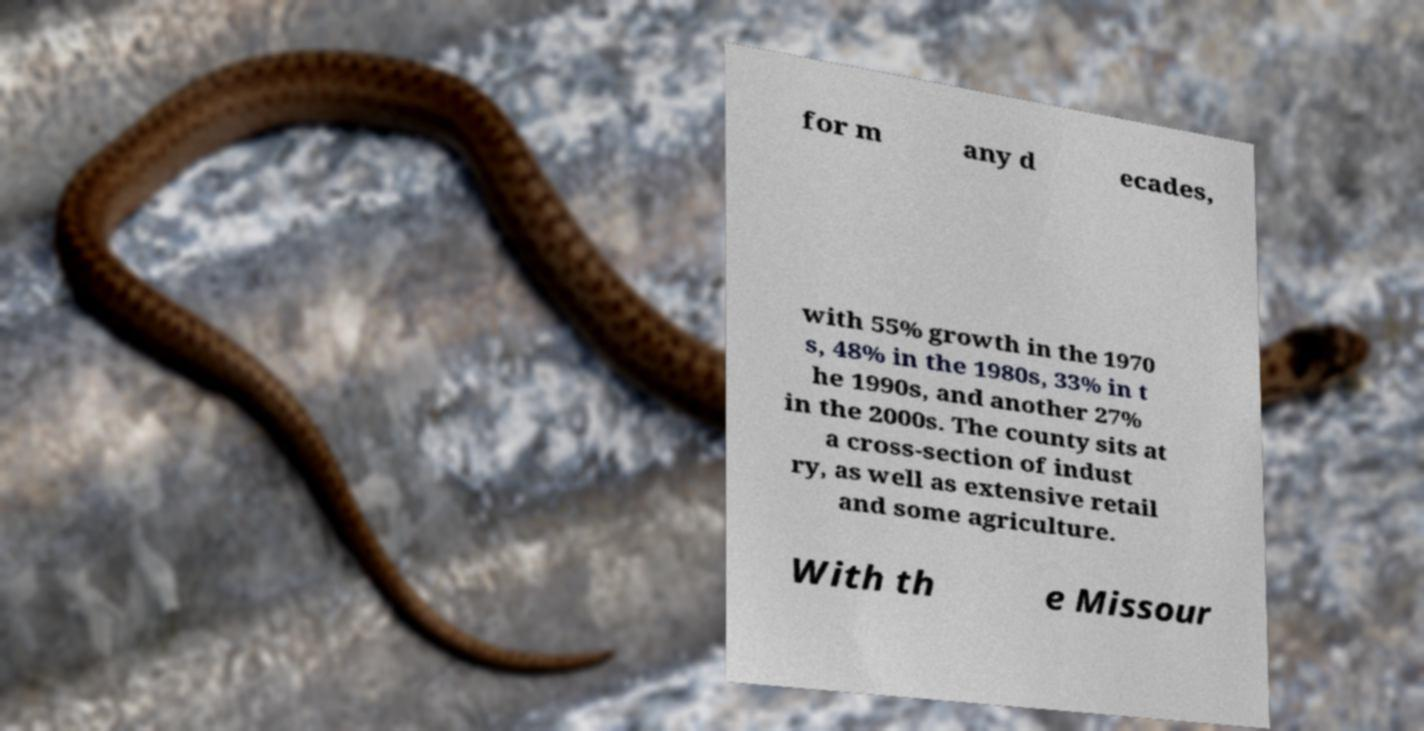Please read and relay the text visible in this image. What does it say? for m any d ecades, with 55% growth in the 1970 s, 48% in the 1980s, 33% in t he 1990s, and another 27% in the 2000s. The county sits at a cross-section of indust ry, as well as extensive retail and some agriculture. With th e Missour 